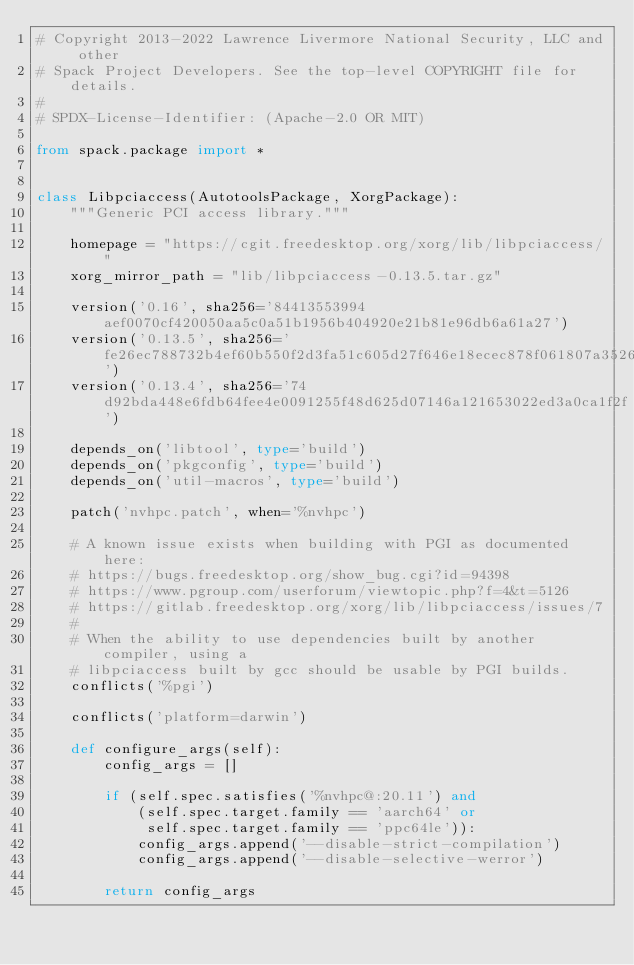Convert code to text. <code><loc_0><loc_0><loc_500><loc_500><_Python_># Copyright 2013-2022 Lawrence Livermore National Security, LLC and other
# Spack Project Developers. See the top-level COPYRIGHT file for details.
#
# SPDX-License-Identifier: (Apache-2.0 OR MIT)

from spack.package import *


class Libpciaccess(AutotoolsPackage, XorgPackage):
    """Generic PCI access library."""

    homepage = "https://cgit.freedesktop.org/xorg/lib/libpciaccess/"
    xorg_mirror_path = "lib/libpciaccess-0.13.5.tar.gz"

    version('0.16', sha256='84413553994aef0070cf420050aa5c0a51b1956b404920e21b81e96db6a61a27')
    version('0.13.5', sha256='fe26ec788732b4ef60b550f2d3fa51c605d27f646e18ecec878f061807a3526e')
    version('0.13.4', sha256='74d92bda448e6fdb64fee4e0091255f48d625d07146a121653022ed3a0ca1f2f')

    depends_on('libtool', type='build')
    depends_on('pkgconfig', type='build')
    depends_on('util-macros', type='build')

    patch('nvhpc.patch', when='%nvhpc')

    # A known issue exists when building with PGI as documented here:
    # https://bugs.freedesktop.org/show_bug.cgi?id=94398
    # https://www.pgroup.com/userforum/viewtopic.php?f=4&t=5126
    # https://gitlab.freedesktop.org/xorg/lib/libpciaccess/issues/7
    #
    # When the ability to use dependencies built by another compiler, using a
    # libpciaccess built by gcc should be usable by PGI builds.
    conflicts('%pgi')

    conflicts('platform=darwin')

    def configure_args(self):
        config_args = []

        if (self.spec.satisfies('%nvhpc@:20.11') and
            (self.spec.target.family == 'aarch64' or
             self.spec.target.family == 'ppc64le')):
            config_args.append('--disable-strict-compilation')
            config_args.append('--disable-selective-werror')

        return config_args
</code> 